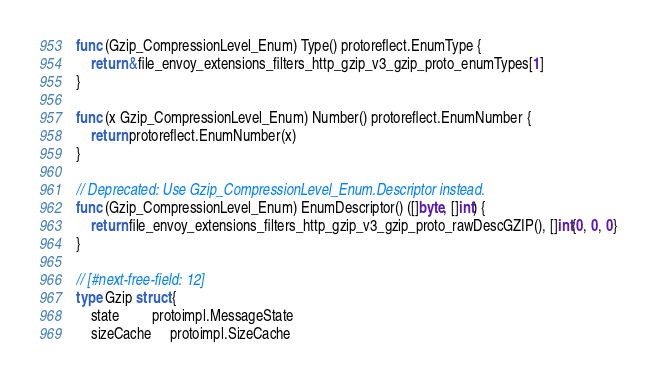Convert code to text. <code><loc_0><loc_0><loc_500><loc_500><_Go_>
func (Gzip_CompressionLevel_Enum) Type() protoreflect.EnumType {
	return &file_envoy_extensions_filters_http_gzip_v3_gzip_proto_enumTypes[1]
}

func (x Gzip_CompressionLevel_Enum) Number() protoreflect.EnumNumber {
	return protoreflect.EnumNumber(x)
}

// Deprecated: Use Gzip_CompressionLevel_Enum.Descriptor instead.
func (Gzip_CompressionLevel_Enum) EnumDescriptor() ([]byte, []int) {
	return file_envoy_extensions_filters_http_gzip_v3_gzip_proto_rawDescGZIP(), []int{0, 0, 0}
}

// [#next-free-field: 12]
type Gzip struct {
	state         protoimpl.MessageState
	sizeCache     protoimpl.SizeCache</code> 